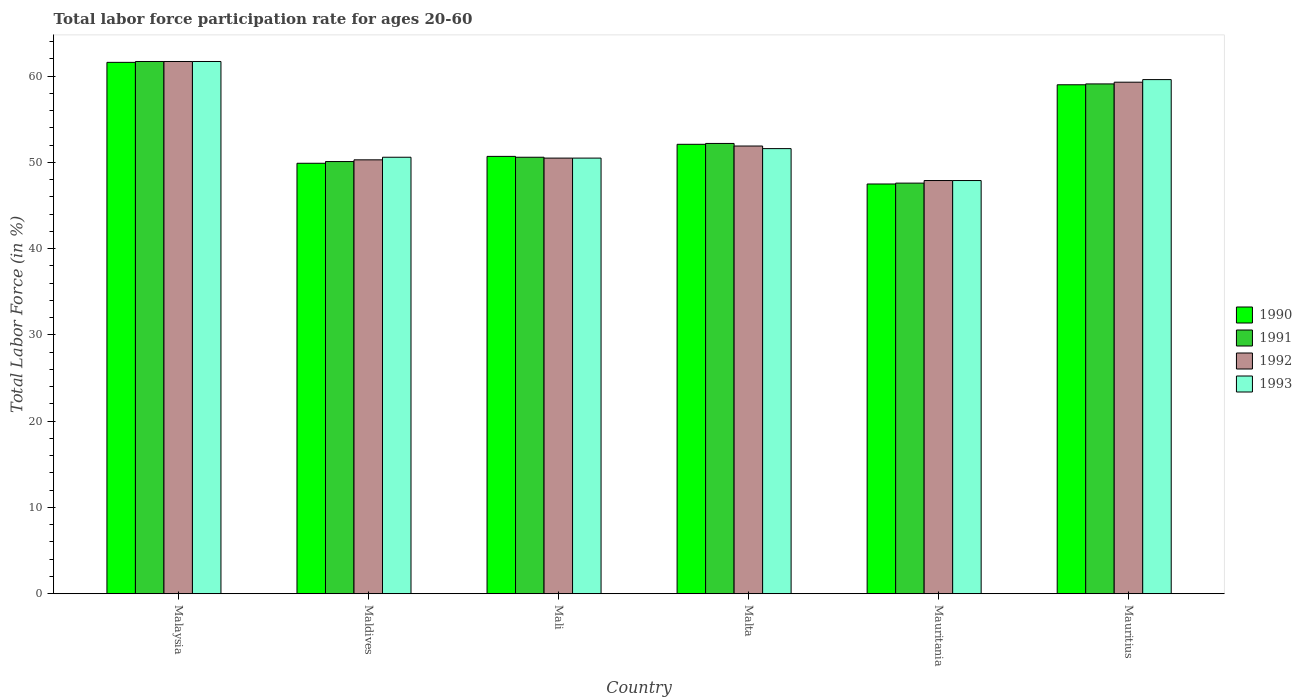Are the number of bars per tick equal to the number of legend labels?
Offer a terse response. Yes. What is the label of the 2nd group of bars from the left?
Offer a terse response. Maldives. What is the labor force participation rate in 1993 in Mali?
Give a very brief answer. 50.5. Across all countries, what is the maximum labor force participation rate in 1993?
Provide a short and direct response. 61.7. Across all countries, what is the minimum labor force participation rate in 1993?
Your response must be concise. 47.9. In which country was the labor force participation rate in 1991 maximum?
Provide a succinct answer. Malaysia. In which country was the labor force participation rate in 1992 minimum?
Ensure brevity in your answer.  Mauritania. What is the total labor force participation rate in 1992 in the graph?
Offer a terse response. 321.6. What is the difference between the labor force participation rate in 1990 in Malaysia and that in Maldives?
Provide a short and direct response. 11.7. What is the difference between the labor force participation rate in 1992 in Mali and the labor force participation rate in 1990 in Malta?
Provide a short and direct response. -1.6. What is the average labor force participation rate in 1990 per country?
Give a very brief answer. 53.47. What is the difference between the labor force participation rate of/in 1991 and labor force participation rate of/in 1990 in Mauritius?
Your answer should be compact. 0.1. In how many countries, is the labor force participation rate in 1992 greater than 18 %?
Give a very brief answer. 6. What is the ratio of the labor force participation rate in 1992 in Malaysia to that in Mauritania?
Your answer should be compact. 1.29. Is the labor force participation rate in 1991 in Maldives less than that in Mali?
Give a very brief answer. Yes. Is the difference between the labor force participation rate in 1991 in Maldives and Mauritius greater than the difference between the labor force participation rate in 1990 in Maldives and Mauritius?
Give a very brief answer. Yes. What is the difference between the highest and the second highest labor force participation rate in 1992?
Provide a succinct answer. -7.4. What is the difference between the highest and the lowest labor force participation rate in 1991?
Ensure brevity in your answer.  14.1. In how many countries, is the labor force participation rate in 1991 greater than the average labor force participation rate in 1991 taken over all countries?
Provide a succinct answer. 2. How many bars are there?
Provide a short and direct response. 24. Are the values on the major ticks of Y-axis written in scientific E-notation?
Ensure brevity in your answer.  No. Where does the legend appear in the graph?
Provide a succinct answer. Center right. How are the legend labels stacked?
Your response must be concise. Vertical. What is the title of the graph?
Give a very brief answer. Total labor force participation rate for ages 20-60. What is the Total Labor Force (in %) in 1990 in Malaysia?
Offer a terse response. 61.6. What is the Total Labor Force (in %) of 1991 in Malaysia?
Provide a succinct answer. 61.7. What is the Total Labor Force (in %) in 1992 in Malaysia?
Ensure brevity in your answer.  61.7. What is the Total Labor Force (in %) of 1993 in Malaysia?
Your answer should be very brief. 61.7. What is the Total Labor Force (in %) of 1990 in Maldives?
Your answer should be compact. 49.9. What is the Total Labor Force (in %) in 1991 in Maldives?
Ensure brevity in your answer.  50.1. What is the Total Labor Force (in %) in 1992 in Maldives?
Provide a succinct answer. 50.3. What is the Total Labor Force (in %) of 1993 in Maldives?
Give a very brief answer. 50.6. What is the Total Labor Force (in %) of 1990 in Mali?
Make the answer very short. 50.7. What is the Total Labor Force (in %) in 1991 in Mali?
Provide a succinct answer. 50.6. What is the Total Labor Force (in %) of 1992 in Mali?
Your answer should be compact. 50.5. What is the Total Labor Force (in %) in 1993 in Mali?
Make the answer very short. 50.5. What is the Total Labor Force (in %) in 1990 in Malta?
Your answer should be compact. 52.1. What is the Total Labor Force (in %) of 1991 in Malta?
Provide a short and direct response. 52.2. What is the Total Labor Force (in %) in 1992 in Malta?
Offer a terse response. 51.9. What is the Total Labor Force (in %) of 1993 in Malta?
Make the answer very short. 51.6. What is the Total Labor Force (in %) of 1990 in Mauritania?
Provide a short and direct response. 47.5. What is the Total Labor Force (in %) of 1991 in Mauritania?
Your answer should be very brief. 47.6. What is the Total Labor Force (in %) of 1992 in Mauritania?
Keep it short and to the point. 47.9. What is the Total Labor Force (in %) in 1993 in Mauritania?
Provide a succinct answer. 47.9. What is the Total Labor Force (in %) of 1991 in Mauritius?
Offer a terse response. 59.1. What is the Total Labor Force (in %) of 1992 in Mauritius?
Provide a succinct answer. 59.3. What is the Total Labor Force (in %) in 1993 in Mauritius?
Give a very brief answer. 59.6. Across all countries, what is the maximum Total Labor Force (in %) in 1990?
Ensure brevity in your answer.  61.6. Across all countries, what is the maximum Total Labor Force (in %) of 1991?
Provide a short and direct response. 61.7. Across all countries, what is the maximum Total Labor Force (in %) of 1992?
Keep it short and to the point. 61.7. Across all countries, what is the maximum Total Labor Force (in %) of 1993?
Make the answer very short. 61.7. Across all countries, what is the minimum Total Labor Force (in %) in 1990?
Give a very brief answer. 47.5. Across all countries, what is the minimum Total Labor Force (in %) in 1991?
Your answer should be very brief. 47.6. Across all countries, what is the minimum Total Labor Force (in %) of 1992?
Ensure brevity in your answer.  47.9. Across all countries, what is the minimum Total Labor Force (in %) of 1993?
Keep it short and to the point. 47.9. What is the total Total Labor Force (in %) in 1990 in the graph?
Your response must be concise. 320.8. What is the total Total Labor Force (in %) of 1991 in the graph?
Provide a succinct answer. 321.3. What is the total Total Labor Force (in %) of 1992 in the graph?
Give a very brief answer. 321.6. What is the total Total Labor Force (in %) in 1993 in the graph?
Keep it short and to the point. 321.9. What is the difference between the Total Labor Force (in %) in 1991 in Malaysia and that in Maldives?
Offer a very short reply. 11.6. What is the difference between the Total Labor Force (in %) in 1992 in Malaysia and that in Maldives?
Make the answer very short. 11.4. What is the difference between the Total Labor Force (in %) of 1990 in Malaysia and that in Mali?
Make the answer very short. 10.9. What is the difference between the Total Labor Force (in %) of 1993 in Malaysia and that in Mali?
Make the answer very short. 11.2. What is the difference between the Total Labor Force (in %) of 1990 in Malaysia and that in Malta?
Your answer should be very brief. 9.5. What is the difference between the Total Labor Force (in %) in 1991 in Malaysia and that in Malta?
Your answer should be compact. 9.5. What is the difference between the Total Labor Force (in %) of 1993 in Malaysia and that in Malta?
Make the answer very short. 10.1. What is the difference between the Total Labor Force (in %) in 1992 in Malaysia and that in Mauritania?
Keep it short and to the point. 13.8. What is the difference between the Total Labor Force (in %) in 1993 in Malaysia and that in Mauritania?
Your response must be concise. 13.8. What is the difference between the Total Labor Force (in %) of 1991 in Malaysia and that in Mauritius?
Your answer should be very brief. 2.6. What is the difference between the Total Labor Force (in %) in 1993 in Malaysia and that in Mauritius?
Your answer should be very brief. 2.1. What is the difference between the Total Labor Force (in %) in 1993 in Maldives and that in Mali?
Give a very brief answer. 0.1. What is the difference between the Total Labor Force (in %) of 1990 in Maldives and that in Malta?
Give a very brief answer. -2.2. What is the difference between the Total Labor Force (in %) of 1991 in Maldives and that in Malta?
Keep it short and to the point. -2.1. What is the difference between the Total Labor Force (in %) of 1992 in Maldives and that in Malta?
Your response must be concise. -1.6. What is the difference between the Total Labor Force (in %) in 1993 in Maldives and that in Malta?
Keep it short and to the point. -1. What is the difference between the Total Labor Force (in %) of 1990 in Maldives and that in Mauritania?
Provide a succinct answer. 2.4. What is the difference between the Total Labor Force (in %) of 1990 in Maldives and that in Mauritius?
Your answer should be compact. -9.1. What is the difference between the Total Labor Force (in %) of 1993 in Maldives and that in Mauritius?
Provide a succinct answer. -9. What is the difference between the Total Labor Force (in %) of 1992 in Mali and that in Malta?
Offer a terse response. -1.4. What is the difference between the Total Labor Force (in %) of 1990 in Mali and that in Mauritania?
Your response must be concise. 3.2. What is the difference between the Total Labor Force (in %) of 1992 in Mali and that in Mauritania?
Keep it short and to the point. 2.6. What is the difference between the Total Labor Force (in %) in 1993 in Mali and that in Mauritania?
Make the answer very short. 2.6. What is the difference between the Total Labor Force (in %) of 1990 in Mali and that in Mauritius?
Your answer should be very brief. -8.3. What is the difference between the Total Labor Force (in %) in 1990 in Malta and that in Mauritania?
Make the answer very short. 4.6. What is the difference between the Total Labor Force (in %) of 1991 in Malta and that in Mauritania?
Offer a terse response. 4.6. What is the difference between the Total Labor Force (in %) of 1992 in Malta and that in Mauritania?
Provide a short and direct response. 4. What is the difference between the Total Labor Force (in %) in 1990 in Malta and that in Mauritius?
Your answer should be compact. -6.9. What is the difference between the Total Labor Force (in %) in 1991 in Malta and that in Mauritius?
Offer a very short reply. -6.9. What is the difference between the Total Labor Force (in %) in 1992 in Malta and that in Mauritius?
Your answer should be very brief. -7.4. What is the difference between the Total Labor Force (in %) of 1990 in Mauritania and that in Mauritius?
Provide a succinct answer. -11.5. What is the difference between the Total Labor Force (in %) in 1992 in Mauritania and that in Mauritius?
Ensure brevity in your answer.  -11.4. What is the difference between the Total Labor Force (in %) of 1993 in Mauritania and that in Mauritius?
Make the answer very short. -11.7. What is the difference between the Total Labor Force (in %) in 1990 in Malaysia and the Total Labor Force (in %) in 1991 in Maldives?
Give a very brief answer. 11.5. What is the difference between the Total Labor Force (in %) in 1990 in Malaysia and the Total Labor Force (in %) in 1992 in Maldives?
Offer a very short reply. 11.3. What is the difference between the Total Labor Force (in %) of 1990 in Malaysia and the Total Labor Force (in %) of 1993 in Maldives?
Your answer should be very brief. 11. What is the difference between the Total Labor Force (in %) of 1992 in Malaysia and the Total Labor Force (in %) of 1993 in Maldives?
Provide a succinct answer. 11.1. What is the difference between the Total Labor Force (in %) of 1990 in Malaysia and the Total Labor Force (in %) of 1991 in Mali?
Offer a terse response. 11. What is the difference between the Total Labor Force (in %) of 1990 in Malaysia and the Total Labor Force (in %) of 1992 in Mali?
Provide a succinct answer. 11.1. What is the difference between the Total Labor Force (in %) in 1990 in Malaysia and the Total Labor Force (in %) in 1993 in Mali?
Make the answer very short. 11.1. What is the difference between the Total Labor Force (in %) of 1990 in Malaysia and the Total Labor Force (in %) of 1991 in Malta?
Your answer should be compact. 9.4. What is the difference between the Total Labor Force (in %) in 1991 in Malaysia and the Total Labor Force (in %) in 1992 in Malta?
Offer a terse response. 9.8. What is the difference between the Total Labor Force (in %) in 1990 in Malaysia and the Total Labor Force (in %) in 1992 in Mauritania?
Offer a very short reply. 13.7. What is the difference between the Total Labor Force (in %) of 1990 in Malaysia and the Total Labor Force (in %) of 1993 in Mauritania?
Offer a terse response. 13.7. What is the difference between the Total Labor Force (in %) in 1991 in Malaysia and the Total Labor Force (in %) in 1993 in Mauritania?
Your answer should be very brief. 13.8. What is the difference between the Total Labor Force (in %) of 1992 in Malaysia and the Total Labor Force (in %) of 1993 in Mauritania?
Make the answer very short. 13.8. What is the difference between the Total Labor Force (in %) of 1990 in Malaysia and the Total Labor Force (in %) of 1991 in Mauritius?
Give a very brief answer. 2.5. What is the difference between the Total Labor Force (in %) of 1990 in Malaysia and the Total Labor Force (in %) of 1993 in Mauritius?
Offer a very short reply. 2. What is the difference between the Total Labor Force (in %) in 1991 in Malaysia and the Total Labor Force (in %) in 1992 in Mauritius?
Your response must be concise. 2.4. What is the difference between the Total Labor Force (in %) in 1991 in Malaysia and the Total Labor Force (in %) in 1993 in Mauritius?
Provide a succinct answer. 2.1. What is the difference between the Total Labor Force (in %) in 1991 in Maldives and the Total Labor Force (in %) in 1993 in Mali?
Provide a short and direct response. -0.4. What is the difference between the Total Labor Force (in %) in 1990 in Maldives and the Total Labor Force (in %) in 1991 in Malta?
Provide a succinct answer. -2.3. What is the difference between the Total Labor Force (in %) of 1991 in Maldives and the Total Labor Force (in %) of 1992 in Malta?
Provide a succinct answer. -1.8. What is the difference between the Total Labor Force (in %) of 1990 in Maldives and the Total Labor Force (in %) of 1991 in Mauritania?
Make the answer very short. 2.3. What is the difference between the Total Labor Force (in %) of 1990 in Maldives and the Total Labor Force (in %) of 1993 in Mauritania?
Keep it short and to the point. 2. What is the difference between the Total Labor Force (in %) of 1991 in Maldives and the Total Labor Force (in %) of 1992 in Mauritania?
Give a very brief answer. 2.2. What is the difference between the Total Labor Force (in %) of 1991 in Maldives and the Total Labor Force (in %) of 1993 in Mauritania?
Your answer should be compact. 2.2. What is the difference between the Total Labor Force (in %) in 1992 in Maldives and the Total Labor Force (in %) in 1993 in Mauritania?
Give a very brief answer. 2.4. What is the difference between the Total Labor Force (in %) of 1990 in Mali and the Total Labor Force (in %) of 1991 in Malta?
Give a very brief answer. -1.5. What is the difference between the Total Labor Force (in %) in 1990 in Mali and the Total Labor Force (in %) in 1992 in Malta?
Give a very brief answer. -1.2. What is the difference between the Total Labor Force (in %) of 1991 in Mali and the Total Labor Force (in %) of 1993 in Malta?
Provide a succinct answer. -1. What is the difference between the Total Labor Force (in %) in 1992 in Mali and the Total Labor Force (in %) in 1993 in Malta?
Make the answer very short. -1.1. What is the difference between the Total Labor Force (in %) in 1990 in Mali and the Total Labor Force (in %) in 1992 in Mauritania?
Keep it short and to the point. 2.8. What is the difference between the Total Labor Force (in %) of 1992 in Mali and the Total Labor Force (in %) of 1993 in Mauritania?
Offer a very short reply. 2.6. What is the difference between the Total Labor Force (in %) in 1990 in Mali and the Total Labor Force (in %) in 1993 in Mauritius?
Provide a short and direct response. -8.9. What is the difference between the Total Labor Force (in %) of 1991 in Mali and the Total Labor Force (in %) of 1992 in Mauritius?
Your response must be concise. -8.7. What is the difference between the Total Labor Force (in %) in 1991 in Mali and the Total Labor Force (in %) in 1993 in Mauritius?
Make the answer very short. -9. What is the difference between the Total Labor Force (in %) in 1990 in Malta and the Total Labor Force (in %) in 1991 in Mauritania?
Give a very brief answer. 4.5. What is the difference between the Total Labor Force (in %) in 1991 in Malta and the Total Labor Force (in %) in 1993 in Mauritania?
Offer a terse response. 4.3. What is the difference between the Total Labor Force (in %) in 1992 in Malta and the Total Labor Force (in %) in 1993 in Mauritania?
Provide a succinct answer. 4. What is the difference between the Total Labor Force (in %) in 1990 in Malta and the Total Labor Force (in %) in 1992 in Mauritius?
Provide a short and direct response. -7.2. What is the difference between the Total Labor Force (in %) of 1990 in Malta and the Total Labor Force (in %) of 1993 in Mauritius?
Provide a succinct answer. -7.5. What is the difference between the Total Labor Force (in %) in 1991 in Malta and the Total Labor Force (in %) in 1992 in Mauritius?
Provide a succinct answer. -7.1. What is the difference between the Total Labor Force (in %) of 1992 in Malta and the Total Labor Force (in %) of 1993 in Mauritius?
Keep it short and to the point. -7.7. What is the difference between the Total Labor Force (in %) in 1990 in Mauritania and the Total Labor Force (in %) in 1992 in Mauritius?
Give a very brief answer. -11.8. What is the difference between the Total Labor Force (in %) of 1991 in Mauritania and the Total Labor Force (in %) of 1992 in Mauritius?
Provide a short and direct response. -11.7. What is the difference between the Total Labor Force (in %) in 1991 in Mauritania and the Total Labor Force (in %) in 1993 in Mauritius?
Offer a very short reply. -12. What is the difference between the Total Labor Force (in %) of 1992 in Mauritania and the Total Labor Force (in %) of 1993 in Mauritius?
Give a very brief answer. -11.7. What is the average Total Labor Force (in %) in 1990 per country?
Your answer should be compact. 53.47. What is the average Total Labor Force (in %) of 1991 per country?
Ensure brevity in your answer.  53.55. What is the average Total Labor Force (in %) of 1992 per country?
Your answer should be compact. 53.6. What is the average Total Labor Force (in %) in 1993 per country?
Give a very brief answer. 53.65. What is the difference between the Total Labor Force (in %) in 1990 and Total Labor Force (in %) in 1991 in Malaysia?
Offer a terse response. -0.1. What is the difference between the Total Labor Force (in %) of 1990 and Total Labor Force (in %) of 1992 in Malaysia?
Make the answer very short. -0.1. What is the difference between the Total Labor Force (in %) in 1990 and Total Labor Force (in %) in 1993 in Malaysia?
Provide a succinct answer. -0.1. What is the difference between the Total Labor Force (in %) in 1992 and Total Labor Force (in %) in 1993 in Malaysia?
Your answer should be very brief. 0. What is the difference between the Total Labor Force (in %) in 1992 and Total Labor Force (in %) in 1993 in Maldives?
Provide a short and direct response. -0.3. What is the difference between the Total Labor Force (in %) of 1990 and Total Labor Force (in %) of 1992 in Mali?
Make the answer very short. 0.2. What is the difference between the Total Labor Force (in %) of 1990 and Total Labor Force (in %) of 1993 in Mali?
Make the answer very short. 0.2. What is the difference between the Total Labor Force (in %) in 1992 and Total Labor Force (in %) in 1993 in Mali?
Your response must be concise. 0. What is the difference between the Total Labor Force (in %) of 1990 and Total Labor Force (in %) of 1992 in Malta?
Your answer should be very brief. 0.2. What is the difference between the Total Labor Force (in %) in 1990 and Total Labor Force (in %) in 1993 in Malta?
Offer a very short reply. 0.5. What is the difference between the Total Labor Force (in %) of 1990 and Total Labor Force (in %) of 1991 in Mauritania?
Provide a short and direct response. -0.1. What is the difference between the Total Labor Force (in %) of 1990 and Total Labor Force (in %) of 1993 in Mauritania?
Ensure brevity in your answer.  -0.4. What is the difference between the Total Labor Force (in %) of 1991 and Total Labor Force (in %) of 1992 in Mauritania?
Your response must be concise. -0.3. What is the difference between the Total Labor Force (in %) in 1991 and Total Labor Force (in %) in 1993 in Mauritania?
Offer a terse response. -0.3. What is the difference between the Total Labor Force (in %) of 1992 and Total Labor Force (in %) of 1993 in Mauritania?
Offer a terse response. 0. What is the difference between the Total Labor Force (in %) of 1990 and Total Labor Force (in %) of 1991 in Mauritius?
Your answer should be compact. -0.1. What is the difference between the Total Labor Force (in %) in 1990 and Total Labor Force (in %) in 1993 in Mauritius?
Your response must be concise. -0.6. What is the ratio of the Total Labor Force (in %) of 1990 in Malaysia to that in Maldives?
Your answer should be compact. 1.23. What is the ratio of the Total Labor Force (in %) of 1991 in Malaysia to that in Maldives?
Ensure brevity in your answer.  1.23. What is the ratio of the Total Labor Force (in %) of 1992 in Malaysia to that in Maldives?
Offer a very short reply. 1.23. What is the ratio of the Total Labor Force (in %) of 1993 in Malaysia to that in Maldives?
Provide a succinct answer. 1.22. What is the ratio of the Total Labor Force (in %) in 1990 in Malaysia to that in Mali?
Provide a succinct answer. 1.22. What is the ratio of the Total Labor Force (in %) of 1991 in Malaysia to that in Mali?
Make the answer very short. 1.22. What is the ratio of the Total Labor Force (in %) in 1992 in Malaysia to that in Mali?
Provide a short and direct response. 1.22. What is the ratio of the Total Labor Force (in %) in 1993 in Malaysia to that in Mali?
Offer a very short reply. 1.22. What is the ratio of the Total Labor Force (in %) of 1990 in Malaysia to that in Malta?
Offer a terse response. 1.18. What is the ratio of the Total Labor Force (in %) in 1991 in Malaysia to that in Malta?
Provide a succinct answer. 1.18. What is the ratio of the Total Labor Force (in %) in 1992 in Malaysia to that in Malta?
Keep it short and to the point. 1.19. What is the ratio of the Total Labor Force (in %) in 1993 in Malaysia to that in Malta?
Your answer should be very brief. 1.2. What is the ratio of the Total Labor Force (in %) of 1990 in Malaysia to that in Mauritania?
Offer a very short reply. 1.3. What is the ratio of the Total Labor Force (in %) in 1991 in Malaysia to that in Mauritania?
Your answer should be compact. 1.3. What is the ratio of the Total Labor Force (in %) of 1992 in Malaysia to that in Mauritania?
Offer a terse response. 1.29. What is the ratio of the Total Labor Force (in %) of 1993 in Malaysia to that in Mauritania?
Provide a succinct answer. 1.29. What is the ratio of the Total Labor Force (in %) in 1990 in Malaysia to that in Mauritius?
Your response must be concise. 1.04. What is the ratio of the Total Labor Force (in %) in 1991 in Malaysia to that in Mauritius?
Your answer should be very brief. 1.04. What is the ratio of the Total Labor Force (in %) of 1992 in Malaysia to that in Mauritius?
Your answer should be compact. 1.04. What is the ratio of the Total Labor Force (in %) of 1993 in Malaysia to that in Mauritius?
Keep it short and to the point. 1.04. What is the ratio of the Total Labor Force (in %) in 1990 in Maldives to that in Mali?
Provide a succinct answer. 0.98. What is the ratio of the Total Labor Force (in %) of 1992 in Maldives to that in Mali?
Provide a short and direct response. 1. What is the ratio of the Total Labor Force (in %) in 1990 in Maldives to that in Malta?
Provide a succinct answer. 0.96. What is the ratio of the Total Labor Force (in %) of 1991 in Maldives to that in Malta?
Your response must be concise. 0.96. What is the ratio of the Total Labor Force (in %) in 1992 in Maldives to that in Malta?
Your answer should be compact. 0.97. What is the ratio of the Total Labor Force (in %) of 1993 in Maldives to that in Malta?
Offer a very short reply. 0.98. What is the ratio of the Total Labor Force (in %) of 1990 in Maldives to that in Mauritania?
Offer a terse response. 1.05. What is the ratio of the Total Labor Force (in %) in 1991 in Maldives to that in Mauritania?
Provide a succinct answer. 1.05. What is the ratio of the Total Labor Force (in %) in 1992 in Maldives to that in Mauritania?
Offer a terse response. 1.05. What is the ratio of the Total Labor Force (in %) of 1993 in Maldives to that in Mauritania?
Keep it short and to the point. 1.06. What is the ratio of the Total Labor Force (in %) in 1990 in Maldives to that in Mauritius?
Your response must be concise. 0.85. What is the ratio of the Total Labor Force (in %) of 1991 in Maldives to that in Mauritius?
Provide a short and direct response. 0.85. What is the ratio of the Total Labor Force (in %) in 1992 in Maldives to that in Mauritius?
Your answer should be compact. 0.85. What is the ratio of the Total Labor Force (in %) in 1993 in Maldives to that in Mauritius?
Give a very brief answer. 0.85. What is the ratio of the Total Labor Force (in %) of 1990 in Mali to that in Malta?
Make the answer very short. 0.97. What is the ratio of the Total Labor Force (in %) in 1991 in Mali to that in Malta?
Give a very brief answer. 0.97. What is the ratio of the Total Labor Force (in %) in 1993 in Mali to that in Malta?
Give a very brief answer. 0.98. What is the ratio of the Total Labor Force (in %) in 1990 in Mali to that in Mauritania?
Offer a very short reply. 1.07. What is the ratio of the Total Labor Force (in %) of 1991 in Mali to that in Mauritania?
Ensure brevity in your answer.  1.06. What is the ratio of the Total Labor Force (in %) of 1992 in Mali to that in Mauritania?
Your answer should be very brief. 1.05. What is the ratio of the Total Labor Force (in %) in 1993 in Mali to that in Mauritania?
Give a very brief answer. 1.05. What is the ratio of the Total Labor Force (in %) in 1990 in Mali to that in Mauritius?
Offer a very short reply. 0.86. What is the ratio of the Total Labor Force (in %) in 1991 in Mali to that in Mauritius?
Your answer should be very brief. 0.86. What is the ratio of the Total Labor Force (in %) in 1992 in Mali to that in Mauritius?
Provide a short and direct response. 0.85. What is the ratio of the Total Labor Force (in %) in 1993 in Mali to that in Mauritius?
Your answer should be very brief. 0.85. What is the ratio of the Total Labor Force (in %) of 1990 in Malta to that in Mauritania?
Your response must be concise. 1.1. What is the ratio of the Total Labor Force (in %) of 1991 in Malta to that in Mauritania?
Keep it short and to the point. 1.1. What is the ratio of the Total Labor Force (in %) of 1992 in Malta to that in Mauritania?
Keep it short and to the point. 1.08. What is the ratio of the Total Labor Force (in %) in 1993 in Malta to that in Mauritania?
Ensure brevity in your answer.  1.08. What is the ratio of the Total Labor Force (in %) of 1990 in Malta to that in Mauritius?
Ensure brevity in your answer.  0.88. What is the ratio of the Total Labor Force (in %) of 1991 in Malta to that in Mauritius?
Your answer should be very brief. 0.88. What is the ratio of the Total Labor Force (in %) in 1992 in Malta to that in Mauritius?
Provide a short and direct response. 0.88. What is the ratio of the Total Labor Force (in %) in 1993 in Malta to that in Mauritius?
Provide a succinct answer. 0.87. What is the ratio of the Total Labor Force (in %) of 1990 in Mauritania to that in Mauritius?
Your answer should be compact. 0.81. What is the ratio of the Total Labor Force (in %) in 1991 in Mauritania to that in Mauritius?
Your answer should be very brief. 0.81. What is the ratio of the Total Labor Force (in %) of 1992 in Mauritania to that in Mauritius?
Keep it short and to the point. 0.81. What is the ratio of the Total Labor Force (in %) of 1993 in Mauritania to that in Mauritius?
Keep it short and to the point. 0.8. What is the difference between the highest and the second highest Total Labor Force (in %) of 1991?
Provide a short and direct response. 2.6. What is the difference between the highest and the second highest Total Labor Force (in %) of 1992?
Offer a terse response. 2.4. What is the difference between the highest and the lowest Total Labor Force (in %) in 1991?
Your answer should be compact. 14.1. What is the difference between the highest and the lowest Total Labor Force (in %) of 1993?
Offer a very short reply. 13.8. 